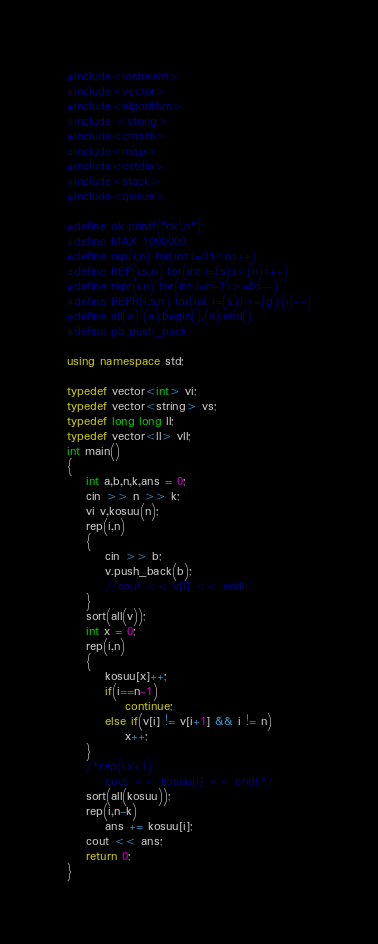Convert code to text. <code><loc_0><loc_0><loc_500><loc_500><_C++_>#include<iostream>
#include<vector>
#include<algorithm>
#include <string>
#include<cmath>
#include<map>
#include<cstdio>
#include<stack>
#include<queue>

#define ok printf("ok\n");
#define MAX 1000000
#define rep(i,n) for(int i=0;i<n;i++)
#define REP(i,s,n) for(int i=(s);i<(n);i++)
#define repr(i,n) for(int i=n-1;i>=0;i--)
#define REPR(i,s,n) for(int i=(s);i>=(g);(i)--)
#define all(a) (a).begin(),(a).end()
#define pb push_back

using namespace std;

typedef vector<int> vi;
typedef vector<string> vs;
typedef long long ll;
typedef vector<ll> vll;
int main()
{
	int a,b,n,k,ans = 0;
	cin >> n >> k;
	vi v,kosuu(n);
	rep(i,n)
	{
		cin >> b;
		v.push_back(b);
		//cout << v[i] << endl;
	}
	sort(all(v));
	int x = 0;
	rep(i,n)
	{
		kosuu[x]++;
		if(i==n-1)
			continue;
		else if(v[i] != v[i+1] && i != n)
			x++;
	}
	/*rep(i,x+1)
		cout << kosuu[i] << endl;*/
	sort(all(kosuu));
	rep(i,n-k)
		ans += kosuu[i];
	cout << ans;
	return 0;
}</code> 